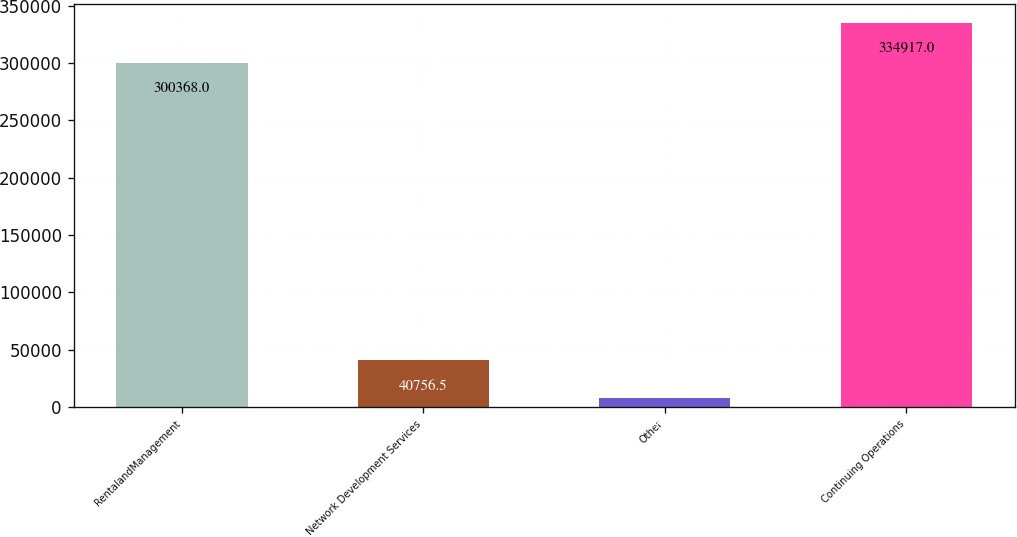<chart> <loc_0><loc_0><loc_500><loc_500><bar_chart><fcel>RentalandManagement<fcel>Network Development Services<fcel>Other<fcel>Continuing Operations<nl><fcel>300368<fcel>40756.5<fcel>8072<fcel>334917<nl></chart> 